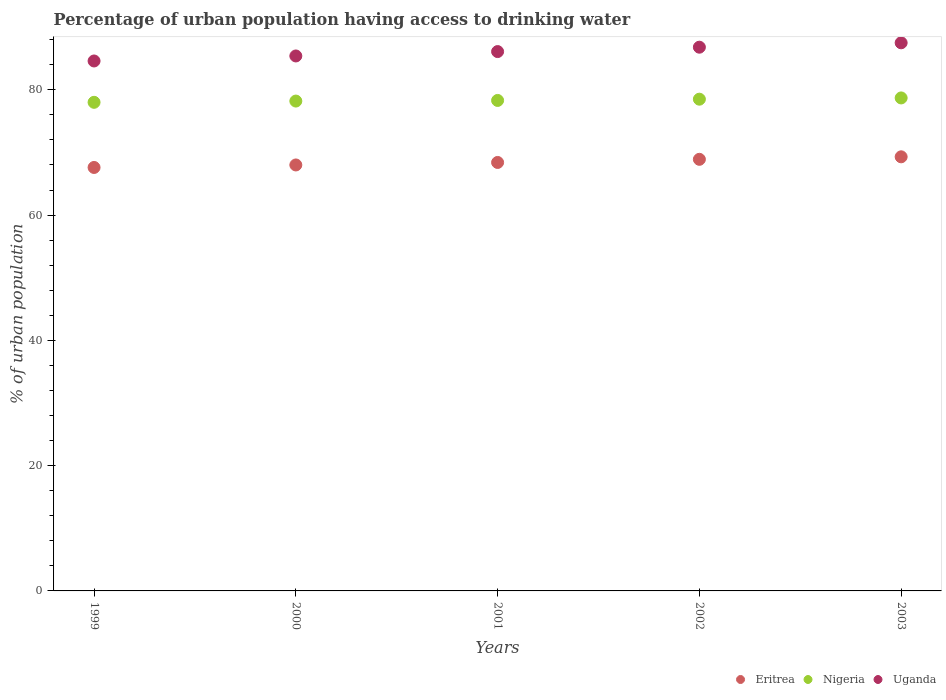What is the percentage of urban population having access to drinking water in Nigeria in 2003?
Make the answer very short. 78.7. Across all years, what is the maximum percentage of urban population having access to drinking water in Eritrea?
Your answer should be compact. 69.3. Across all years, what is the minimum percentage of urban population having access to drinking water in Nigeria?
Your answer should be compact. 78. In which year was the percentage of urban population having access to drinking water in Eritrea maximum?
Your answer should be compact. 2003. In which year was the percentage of urban population having access to drinking water in Nigeria minimum?
Give a very brief answer. 1999. What is the total percentage of urban population having access to drinking water in Eritrea in the graph?
Your response must be concise. 342.2. What is the difference between the percentage of urban population having access to drinking water in Uganda in 2001 and that in 2002?
Offer a very short reply. -0.7. What is the difference between the percentage of urban population having access to drinking water in Eritrea in 1999 and the percentage of urban population having access to drinking water in Nigeria in 2000?
Your answer should be very brief. -10.6. What is the average percentage of urban population having access to drinking water in Eritrea per year?
Make the answer very short. 68.44. In the year 2001, what is the difference between the percentage of urban population having access to drinking water in Eritrea and percentage of urban population having access to drinking water in Nigeria?
Your response must be concise. -9.9. What is the ratio of the percentage of urban population having access to drinking water in Eritrea in 2000 to that in 2002?
Give a very brief answer. 0.99. What is the difference between the highest and the second highest percentage of urban population having access to drinking water in Eritrea?
Provide a succinct answer. 0.4. What is the difference between the highest and the lowest percentage of urban population having access to drinking water in Eritrea?
Your response must be concise. 1.7. In how many years, is the percentage of urban population having access to drinking water in Uganda greater than the average percentage of urban population having access to drinking water in Uganda taken over all years?
Offer a very short reply. 3. Is the sum of the percentage of urban population having access to drinking water in Uganda in 2002 and 2003 greater than the maximum percentage of urban population having access to drinking water in Eritrea across all years?
Your answer should be very brief. Yes. Is the percentage of urban population having access to drinking water in Nigeria strictly greater than the percentage of urban population having access to drinking water in Eritrea over the years?
Give a very brief answer. Yes. How many dotlines are there?
Your answer should be compact. 3. Does the graph contain any zero values?
Keep it short and to the point. No. How are the legend labels stacked?
Your response must be concise. Horizontal. What is the title of the graph?
Offer a very short reply. Percentage of urban population having access to drinking water. Does "Mali" appear as one of the legend labels in the graph?
Ensure brevity in your answer.  No. What is the label or title of the X-axis?
Offer a very short reply. Years. What is the label or title of the Y-axis?
Offer a terse response. % of urban population. What is the % of urban population of Eritrea in 1999?
Your answer should be very brief. 67.6. What is the % of urban population in Nigeria in 1999?
Your answer should be compact. 78. What is the % of urban population in Uganda in 1999?
Offer a terse response. 84.6. What is the % of urban population in Nigeria in 2000?
Keep it short and to the point. 78.2. What is the % of urban population of Uganda in 2000?
Offer a terse response. 85.4. What is the % of urban population in Eritrea in 2001?
Your answer should be compact. 68.4. What is the % of urban population of Nigeria in 2001?
Give a very brief answer. 78.3. What is the % of urban population of Uganda in 2001?
Give a very brief answer. 86.1. What is the % of urban population of Eritrea in 2002?
Ensure brevity in your answer.  68.9. What is the % of urban population in Nigeria in 2002?
Ensure brevity in your answer.  78.5. What is the % of urban population of Uganda in 2002?
Provide a short and direct response. 86.8. What is the % of urban population of Eritrea in 2003?
Offer a terse response. 69.3. What is the % of urban population in Nigeria in 2003?
Provide a succinct answer. 78.7. What is the % of urban population in Uganda in 2003?
Offer a terse response. 87.5. Across all years, what is the maximum % of urban population in Eritrea?
Provide a short and direct response. 69.3. Across all years, what is the maximum % of urban population of Nigeria?
Ensure brevity in your answer.  78.7. Across all years, what is the maximum % of urban population in Uganda?
Keep it short and to the point. 87.5. Across all years, what is the minimum % of urban population of Eritrea?
Offer a very short reply. 67.6. Across all years, what is the minimum % of urban population of Nigeria?
Keep it short and to the point. 78. Across all years, what is the minimum % of urban population of Uganda?
Your response must be concise. 84.6. What is the total % of urban population in Eritrea in the graph?
Your answer should be very brief. 342.2. What is the total % of urban population in Nigeria in the graph?
Make the answer very short. 391.7. What is the total % of urban population in Uganda in the graph?
Your response must be concise. 430.4. What is the difference between the % of urban population of Eritrea in 1999 and that in 2000?
Provide a short and direct response. -0.4. What is the difference between the % of urban population in Uganda in 1999 and that in 2000?
Your answer should be compact. -0.8. What is the difference between the % of urban population of Eritrea in 1999 and that in 2001?
Provide a succinct answer. -0.8. What is the difference between the % of urban population of Nigeria in 1999 and that in 2001?
Provide a short and direct response. -0.3. What is the difference between the % of urban population of Uganda in 1999 and that in 2001?
Your answer should be compact. -1.5. What is the difference between the % of urban population of Eritrea in 1999 and that in 2002?
Make the answer very short. -1.3. What is the difference between the % of urban population of Nigeria in 1999 and that in 2002?
Ensure brevity in your answer.  -0.5. What is the difference between the % of urban population in Nigeria in 1999 and that in 2003?
Your answer should be very brief. -0.7. What is the difference between the % of urban population in Uganda in 1999 and that in 2003?
Provide a short and direct response. -2.9. What is the difference between the % of urban population in Nigeria in 2000 and that in 2001?
Your answer should be very brief. -0.1. What is the difference between the % of urban population of Uganda in 2000 and that in 2002?
Offer a very short reply. -1.4. What is the difference between the % of urban population of Nigeria in 2001 and that in 2002?
Provide a succinct answer. -0.2. What is the difference between the % of urban population in Uganda in 2001 and that in 2002?
Keep it short and to the point. -0.7. What is the difference between the % of urban population in Eritrea in 2001 and that in 2003?
Offer a terse response. -0.9. What is the difference between the % of urban population in Eritrea in 1999 and the % of urban population in Uganda in 2000?
Keep it short and to the point. -17.8. What is the difference between the % of urban population in Nigeria in 1999 and the % of urban population in Uganda in 2000?
Your answer should be compact. -7.4. What is the difference between the % of urban population of Eritrea in 1999 and the % of urban population of Uganda in 2001?
Your answer should be compact. -18.5. What is the difference between the % of urban population in Eritrea in 1999 and the % of urban population in Uganda in 2002?
Offer a very short reply. -19.2. What is the difference between the % of urban population of Eritrea in 1999 and the % of urban population of Uganda in 2003?
Ensure brevity in your answer.  -19.9. What is the difference between the % of urban population of Eritrea in 2000 and the % of urban population of Uganda in 2001?
Provide a succinct answer. -18.1. What is the difference between the % of urban population of Nigeria in 2000 and the % of urban population of Uganda in 2001?
Ensure brevity in your answer.  -7.9. What is the difference between the % of urban population of Eritrea in 2000 and the % of urban population of Nigeria in 2002?
Provide a short and direct response. -10.5. What is the difference between the % of urban population of Eritrea in 2000 and the % of urban population of Uganda in 2002?
Offer a very short reply. -18.8. What is the difference between the % of urban population of Eritrea in 2000 and the % of urban population of Nigeria in 2003?
Your answer should be very brief. -10.7. What is the difference between the % of urban population of Eritrea in 2000 and the % of urban population of Uganda in 2003?
Keep it short and to the point. -19.5. What is the difference between the % of urban population of Nigeria in 2000 and the % of urban population of Uganda in 2003?
Make the answer very short. -9.3. What is the difference between the % of urban population of Eritrea in 2001 and the % of urban population of Nigeria in 2002?
Keep it short and to the point. -10.1. What is the difference between the % of urban population in Eritrea in 2001 and the % of urban population in Uganda in 2002?
Keep it short and to the point. -18.4. What is the difference between the % of urban population in Eritrea in 2001 and the % of urban population in Nigeria in 2003?
Your answer should be compact. -10.3. What is the difference between the % of urban population of Eritrea in 2001 and the % of urban population of Uganda in 2003?
Offer a very short reply. -19.1. What is the difference between the % of urban population in Nigeria in 2001 and the % of urban population in Uganda in 2003?
Your response must be concise. -9.2. What is the difference between the % of urban population in Eritrea in 2002 and the % of urban population in Uganda in 2003?
Give a very brief answer. -18.6. What is the difference between the % of urban population in Nigeria in 2002 and the % of urban population in Uganda in 2003?
Your answer should be very brief. -9. What is the average % of urban population of Eritrea per year?
Your answer should be compact. 68.44. What is the average % of urban population in Nigeria per year?
Your answer should be compact. 78.34. What is the average % of urban population in Uganda per year?
Make the answer very short. 86.08. In the year 1999, what is the difference between the % of urban population in Eritrea and % of urban population in Nigeria?
Provide a short and direct response. -10.4. In the year 1999, what is the difference between the % of urban population in Nigeria and % of urban population in Uganda?
Offer a terse response. -6.6. In the year 2000, what is the difference between the % of urban population of Eritrea and % of urban population of Nigeria?
Offer a very short reply. -10.2. In the year 2000, what is the difference between the % of urban population of Eritrea and % of urban population of Uganda?
Ensure brevity in your answer.  -17.4. In the year 2001, what is the difference between the % of urban population of Eritrea and % of urban population of Nigeria?
Your answer should be compact. -9.9. In the year 2001, what is the difference between the % of urban population of Eritrea and % of urban population of Uganda?
Keep it short and to the point. -17.7. In the year 2002, what is the difference between the % of urban population in Eritrea and % of urban population in Uganda?
Provide a succinct answer. -17.9. In the year 2002, what is the difference between the % of urban population of Nigeria and % of urban population of Uganda?
Ensure brevity in your answer.  -8.3. In the year 2003, what is the difference between the % of urban population of Eritrea and % of urban population of Nigeria?
Provide a short and direct response. -9.4. In the year 2003, what is the difference between the % of urban population in Eritrea and % of urban population in Uganda?
Keep it short and to the point. -18.2. What is the ratio of the % of urban population in Uganda in 1999 to that in 2000?
Ensure brevity in your answer.  0.99. What is the ratio of the % of urban population of Eritrea in 1999 to that in 2001?
Keep it short and to the point. 0.99. What is the ratio of the % of urban population of Nigeria in 1999 to that in 2001?
Your answer should be compact. 1. What is the ratio of the % of urban population in Uganda in 1999 to that in 2001?
Keep it short and to the point. 0.98. What is the ratio of the % of urban population in Eritrea in 1999 to that in 2002?
Your answer should be very brief. 0.98. What is the ratio of the % of urban population of Nigeria in 1999 to that in 2002?
Offer a very short reply. 0.99. What is the ratio of the % of urban population in Uganda in 1999 to that in 2002?
Make the answer very short. 0.97. What is the ratio of the % of urban population in Eritrea in 1999 to that in 2003?
Ensure brevity in your answer.  0.98. What is the ratio of the % of urban population in Nigeria in 1999 to that in 2003?
Offer a terse response. 0.99. What is the ratio of the % of urban population in Uganda in 1999 to that in 2003?
Offer a very short reply. 0.97. What is the ratio of the % of urban population in Nigeria in 2000 to that in 2001?
Your answer should be very brief. 1. What is the ratio of the % of urban population of Uganda in 2000 to that in 2001?
Offer a terse response. 0.99. What is the ratio of the % of urban population in Eritrea in 2000 to that in 2002?
Your answer should be very brief. 0.99. What is the ratio of the % of urban population of Uganda in 2000 to that in 2002?
Your response must be concise. 0.98. What is the ratio of the % of urban population in Eritrea in 2000 to that in 2003?
Offer a very short reply. 0.98. What is the ratio of the % of urban population of Nigeria in 2000 to that in 2003?
Give a very brief answer. 0.99. What is the ratio of the % of urban population in Nigeria in 2001 to that in 2002?
Give a very brief answer. 1. What is the ratio of the % of urban population in Uganda in 2001 to that in 2002?
Give a very brief answer. 0.99. What is the ratio of the % of urban population in Nigeria in 2001 to that in 2003?
Your answer should be very brief. 0.99. What is the ratio of the % of urban population in Eritrea in 2002 to that in 2003?
Ensure brevity in your answer.  0.99. What is the ratio of the % of urban population of Nigeria in 2002 to that in 2003?
Keep it short and to the point. 1. What is the difference between the highest and the second highest % of urban population of Eritrea?
Offer a very short reply. 0.4. What is the difference between the highest and the second highest % of urban population in Nigeria?
Give a very brief answer. 0.2. What is the difference between the highest and the second highest % of urban population in Uganda?
Offer a terse response. 0.7. What is the difference between the highest and the lowest % of urban population of Eritrea?
Your answer should be compact. 1.7. What is the difference between the highest and the lowest % of urban population in Nigeria?
Give a very brief answer. 0.7. 